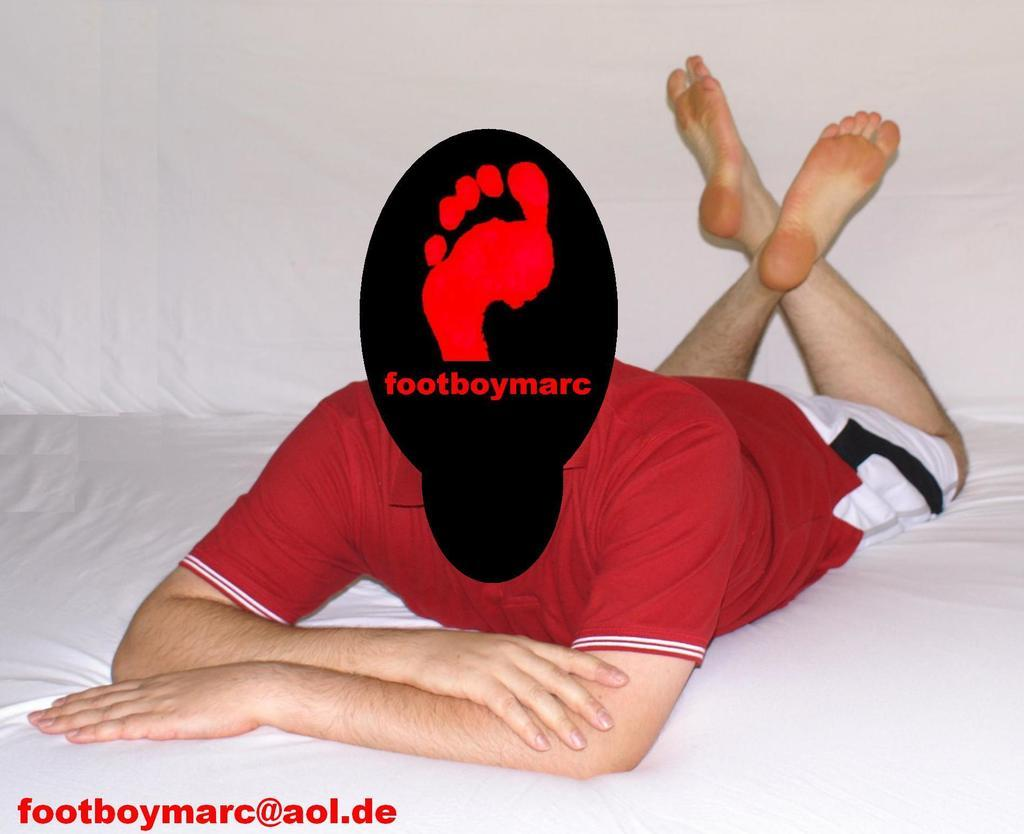<image>
Offer a succinct explanation of the picture presented. Young man laying on a bed with a black and red spot over his face that says "footboymarc" and directs viewers to visit foodboymarc@aol.de. 